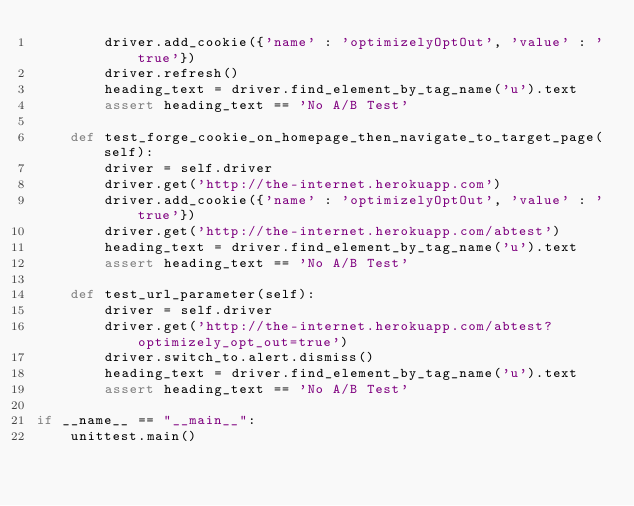Convert code to text. <code><loc_0><loc_0><loc_500><loc_500><_Python_>        driver.add_cookie({'name' : 'optimizelyOptOut', 'value' : 'true'})
        driver.refresh()
        heading_text = driver.find_element_by_tag_name('u').text
        assert heading_text == 'No A/B Test'
    
    def test_forge_cookie_on_homepage_then_navigate_to_target_page(self):
        driver = self.driver
        driver.get('http://the-internet.herokuapp.com')
        driver.add_cookie({'name' : 'optimizelyOptOut', 'value' : 'true'})
        driver.get('http://the-internet.herokuapp.com/abtest')
        heading_text = driver.find_element_by_tag_name('u').text
        assert heading_text == 'No A/B Test'
        
    def test_url_parameter(self):
        driver = self.driver
        driver.get('http://the-internet.herokuapp.com/abtest?optimizely_opt_out=true')
        driver.switch_to.alert.dismiss()
        heading_text = driver.find_element_by_tag_name('u').text
        assert heading_text == 'No A/B Test'

if __name__ == "__main__":
    unittest.main()
</code> 